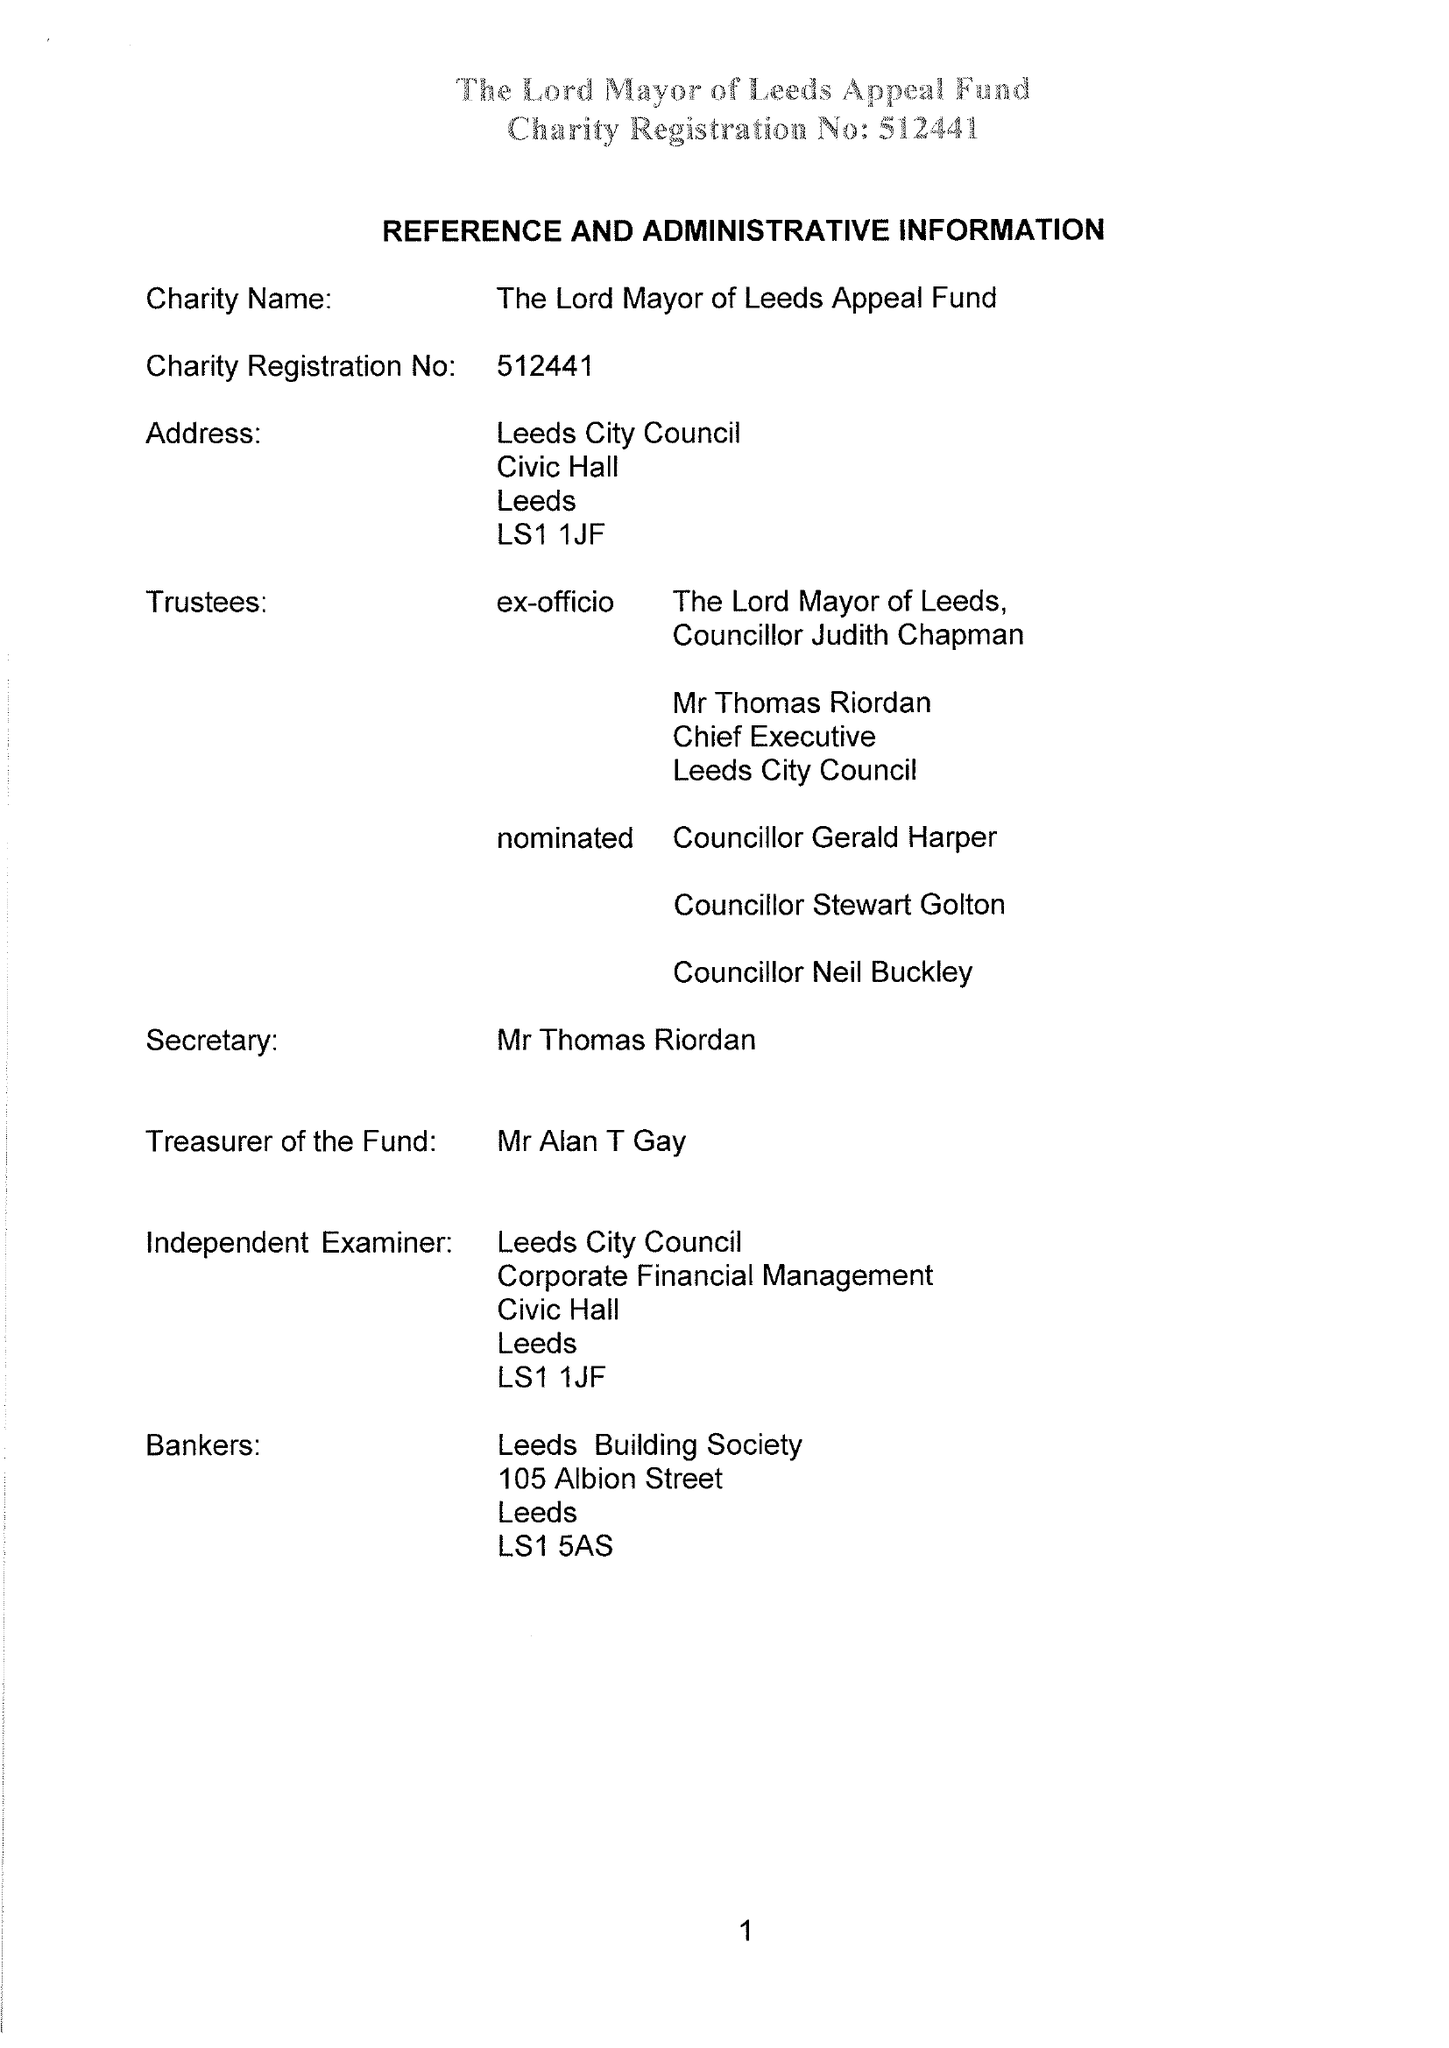What is the value for the address__postcode?
Answer the question using a single word or phrase. LS1 1JF 